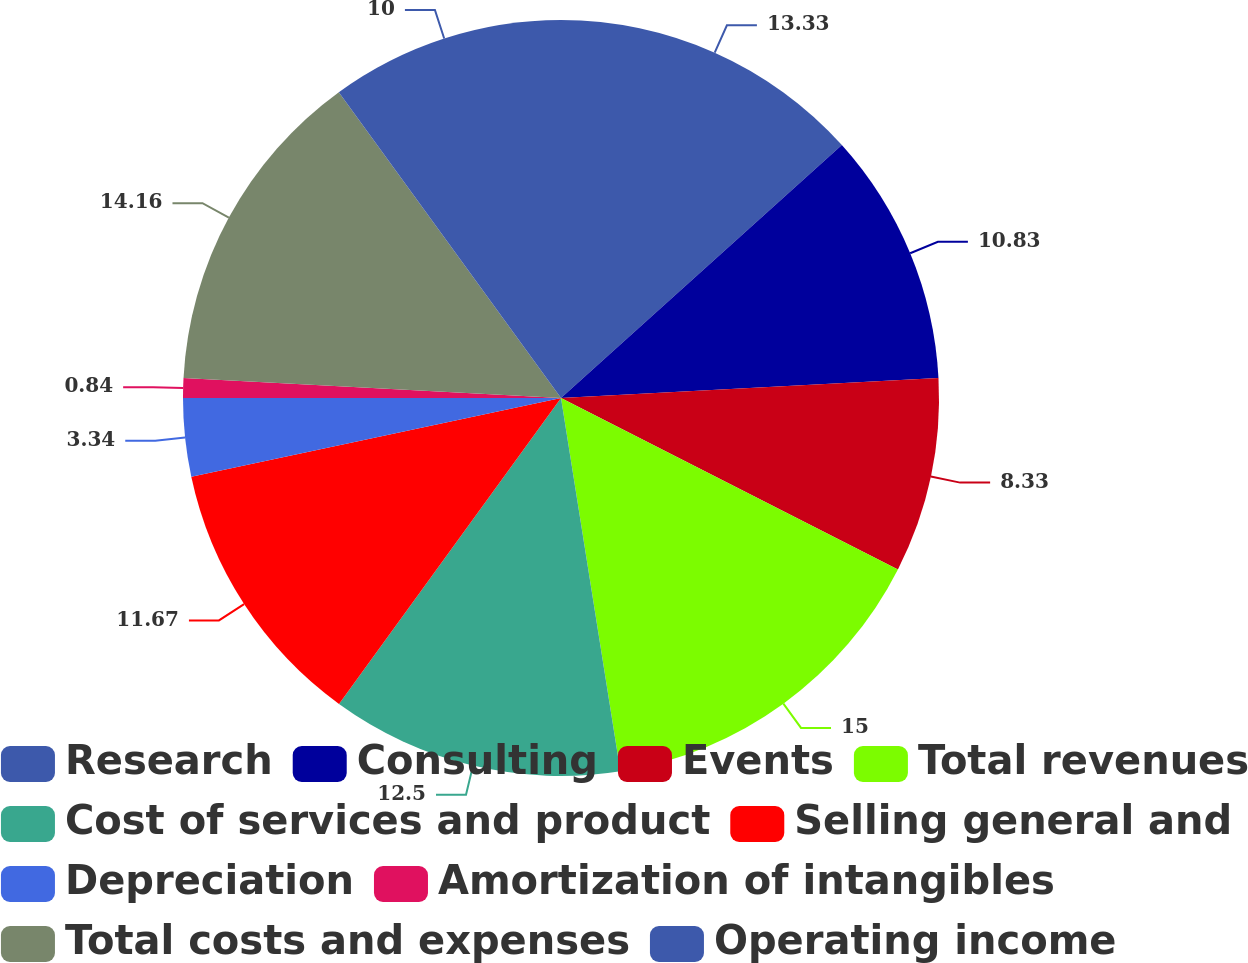Convert chart. <chart><loc_0><loc_0><loc_500><loc_500><pie_chart><fcel>Research<fcel>Consulting<fcel>Events<fcel>Total revenues<fcel>Cost of services and product<fcel>Selling general and<fcel>Depreciation<fcel>Amortization of intangibles<fcel>Total costs and expenses<fcel>Operating income<nl><fcel>13.33%<fcel>10.83%<fcel>8.33%<fcel>15.0%<fcel>12.5%<fcel>11.67%<fcel>3.34%<fcel>0.84%<fcel>14.16%<fcel>10.0%<nl></chart> 